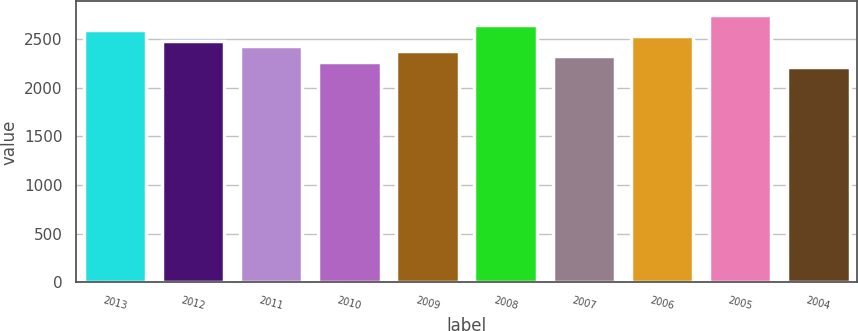Convert chart to OTSL. <chart><loc_0><loc_0><loc_500><loc_500><bar_chart><fcel>2013<fcel>2012<fcel>2011<fcel>2010<fcel>2009<fcel>2008<fcel>2007<fcel>2006<fcel>2005<fcel>2004<nl><fcel>2589.8<fcel>2483<fcel>2429.6<fcel>2269.4<fcel>2376.2<fcel>2643.2<fcel>2322.8<fcel>2536.4<fcel>2750<fcel>2216<nl></chart> 